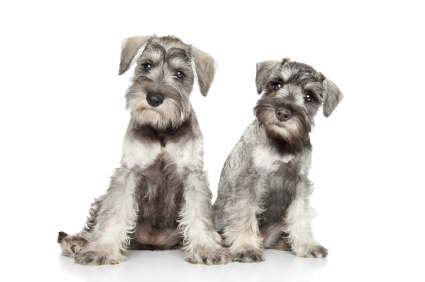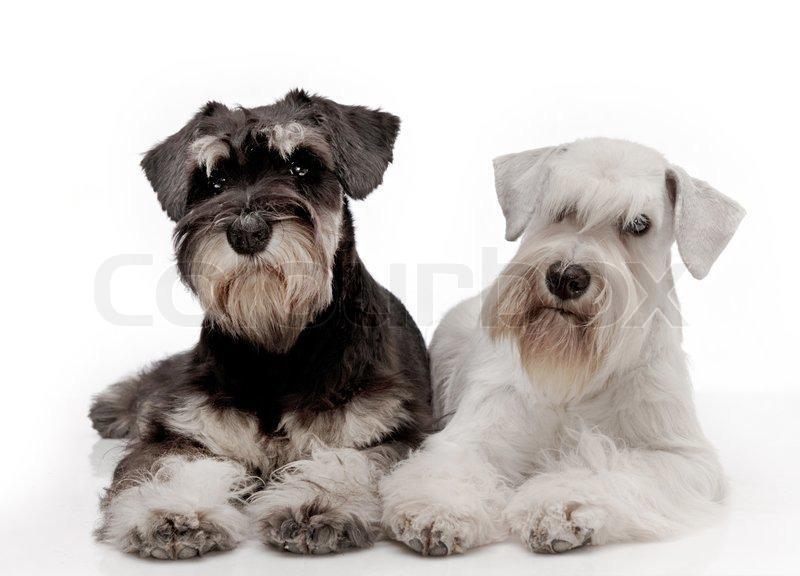The first image is the image on the left, the second image is the image on the right. Assess this claim about the two images: "Each image contains the same number of dogs, and the dogs in both images are posed similarly.". Correct or not? Answer yes or no. Yes. 